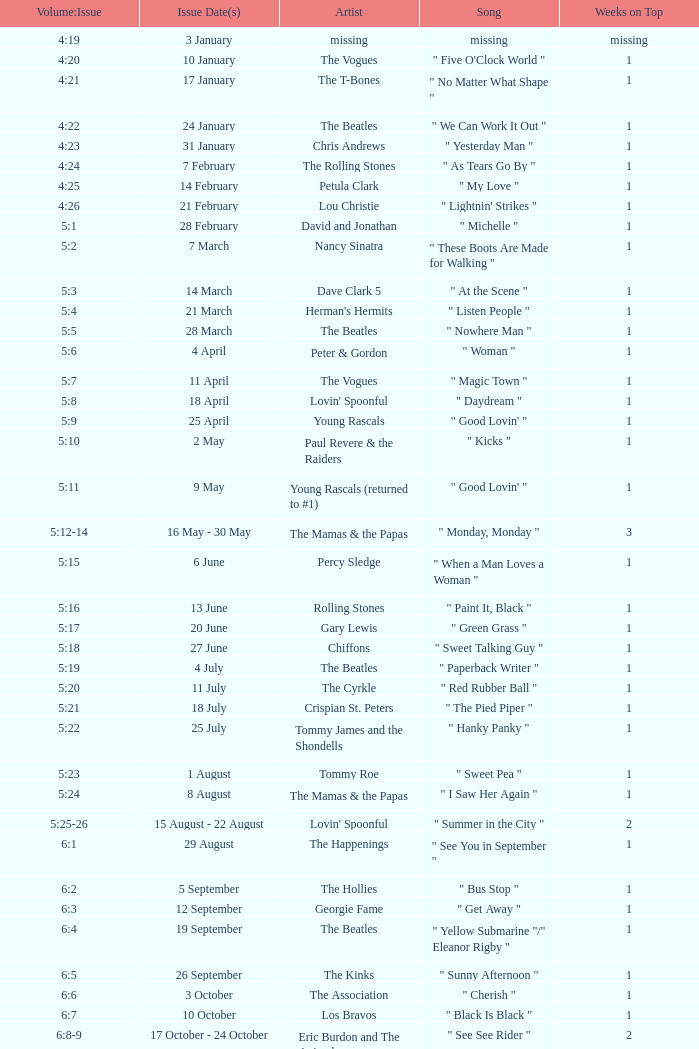Volume:Issue of 5:16 has what song listed? " Paint It, Black ". 